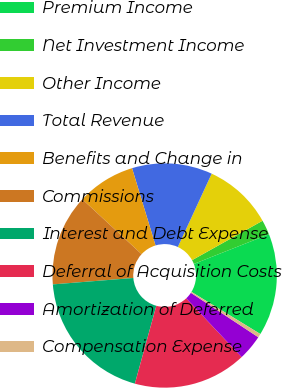<chart> <loc_0><loc_0><loc_500><loc_500><pie_chart><fcel>Premium Income<fcel>Net Investment Income<fcel>Other Income<fcel>Total Revenue<fcel>Benefits and Change in<fcel>Commissions<fcel>Interest and Debt Expense<fcel>Deferral of Acquisition Costs<fcel>Amortization of Deferred<fcel>Compensation Expense<nl><fcel>14.73%<fcel>2.12%<fcel>10.0%<fcel>11.58%<fcel>8.42%<fcel>13.15%<fcel>19.46%<fcel>16.31%<fcel>3.69%<fcel>0.54%<nl></chart> 